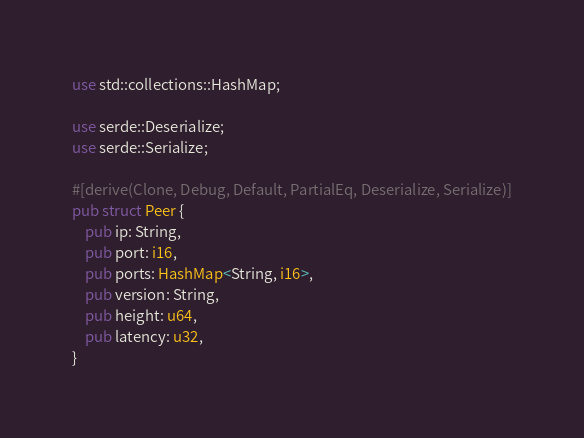Convert code to text. <code><loc_0><loc_0><loc_500><loc_500><_Rust_>use std::collections::HashMap;

use serde::Deserialize;
use serde::Serialize;

#[derive(Clone, Debug, Default, PartialEq, Deserialize, Serialize)]
pub struct Peer {
    pub ip: String,
    pub port: i16,
    pub ports: HashMap<String, i16>,
    pub version: String,
    pub height: u64,
    pub latency: u32,
}
</code> 